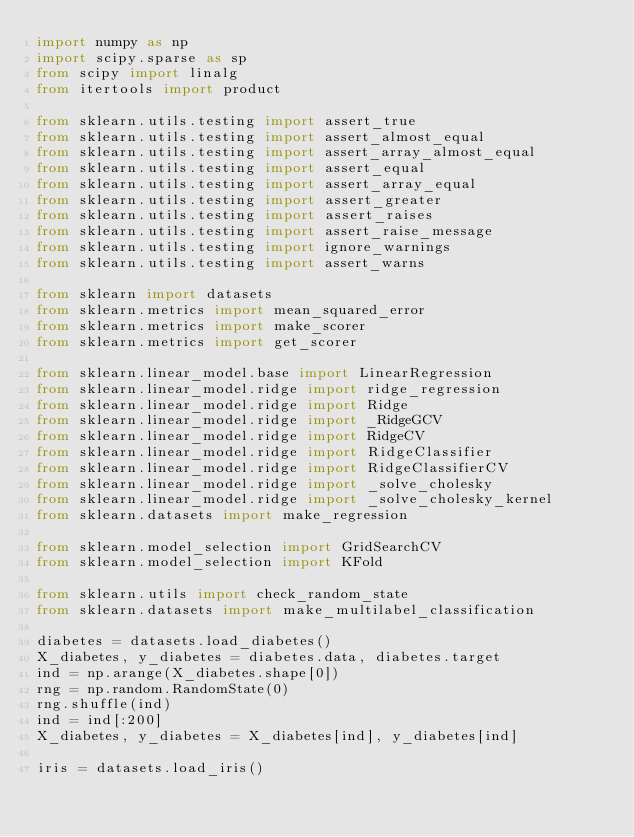<code> <loc_0><loc_0><loc_500><loc_500><_Python_>import numpy as np
import scipy.sparse as sp
from scipy import linalg
from itertools import product

from sklearn.utils.testing import assert_true
from sklearn.utils.testing import assert_almost_equal
from sklearn.utils.testing import assert_array_almost_equal
from sklearn.utils.testing import assert_equal
from sklearn.utils.testing import assert_array_equal
from sklearn.utils.testing import assert_greater
from sklearn.utils.testing import assert_raises
from sklearn.utils.testing import assert_raise_message
from sklearn.utils.testing import ignore_warnings
from sklearn.utils.testing import assert_warns

from sklearn import datasets
from sklearn.metrics import mean_squared_error
from sklearn.metrics import make_scorer
from sklearn.metrics import get_scorer

from sklearn.linear_model.base import LinearRegression
from sklearn.linear_model.ridge import ridge_regression
from sklearn.linear_model.ridge import Ridge
from sklearn.linear_model.ridge import _RidgeGCV
from sklearn.linear_model.ridge import RidgeCV
from sklearn.linear_model.ridge import RidgeClassifier
from sklearn.linear_model.ridge import RidgeClassifierCV
from sklearn.linear_model.ridge import _solve_cholesky
from sklearn.linear_model.ridge import _solve_cholesky_kernel
from sklearn.datasets import make_regression

from sklearn.model_selection import GridSearchCV
from sklearn.model_selection import KFold

from sklearn.utils import check_random_state
from sklearn.datasets import make_multilabel_classification

diabetes = datasets.load_diabetes()
X_diabetes, y_diabetes = diabetes.data, diabetes.target
ind = np.arange(X_diabetes.shape[0])
rng = np.random.RandomState(0)
rng.shuffle(ind)
ind = ind[:200]
X_diabetes, y_diabetes = X_diabetes[ind], y_diabetes[ind]

iris = datasets.load_iris()
</code> 